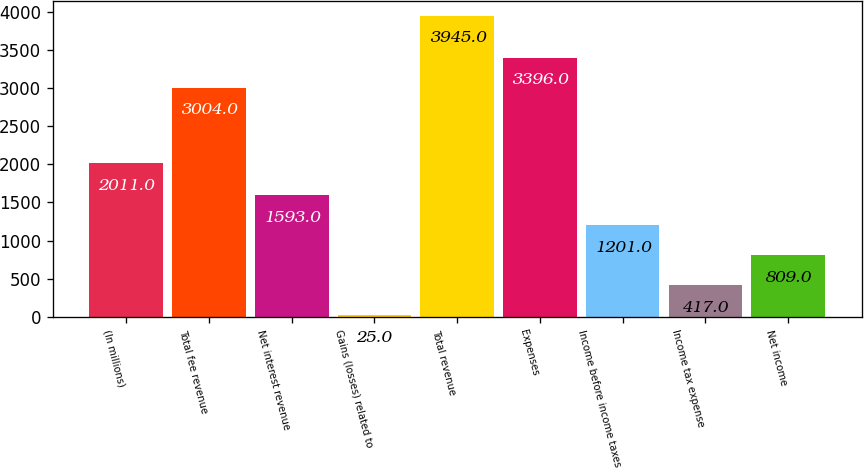Convert chart. <chart><loc_0><loc_0><loc_500><loc_500><bar_chart><fcel>(In millions)<fcel>Total fee revenue<fcel>Net interest revenue<fcel>Gains (losses) related to<fcel>Total revenue<fcel>Expenses<fcel>Income before income taxes<fcel>Income tax expense<fcel>Net income<nl><fcel>2011<fcel>3004<fcel>1593<fcel>25<fcel>3945<fcel>3396<fcel>1201<fcel>417<fcel>809<nl></chart> 